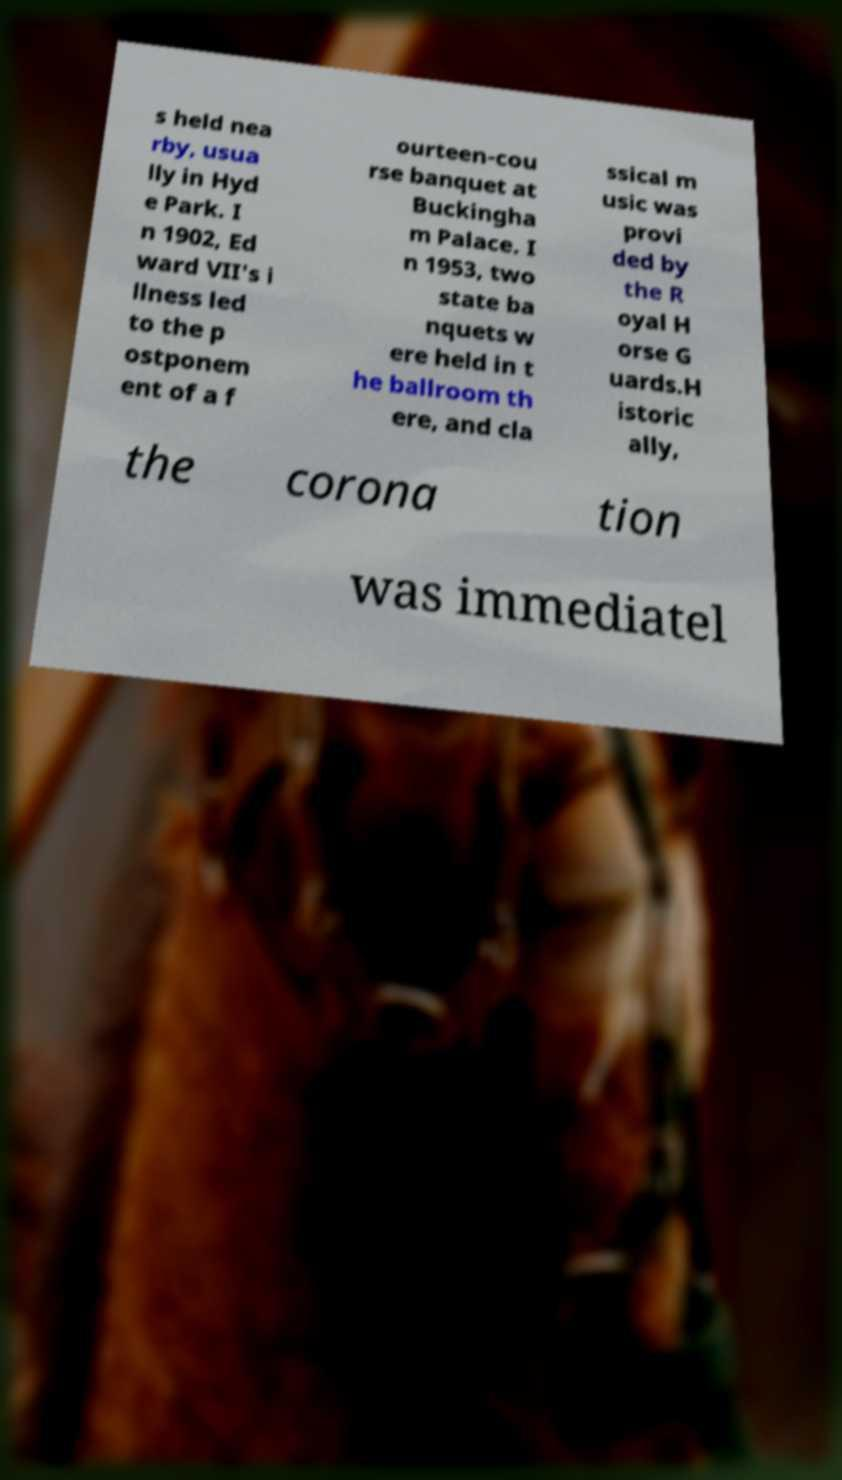Could you assist in decoding the text presented in this image and type it out clearly? s held nea rby, usua lly in Hyd e Park. I n 1902, Ed ward VII's i llness led to the p ostponem ent of a f ourteen-cou rse banquet at Buckingha m Palace. I n 1953, two state ba nquets w ere held in t he ballroom th ere, and cla ssical m usic was provi ded by the R oyal H orse G uards.H istoric ally, the corona tion was immediatel 